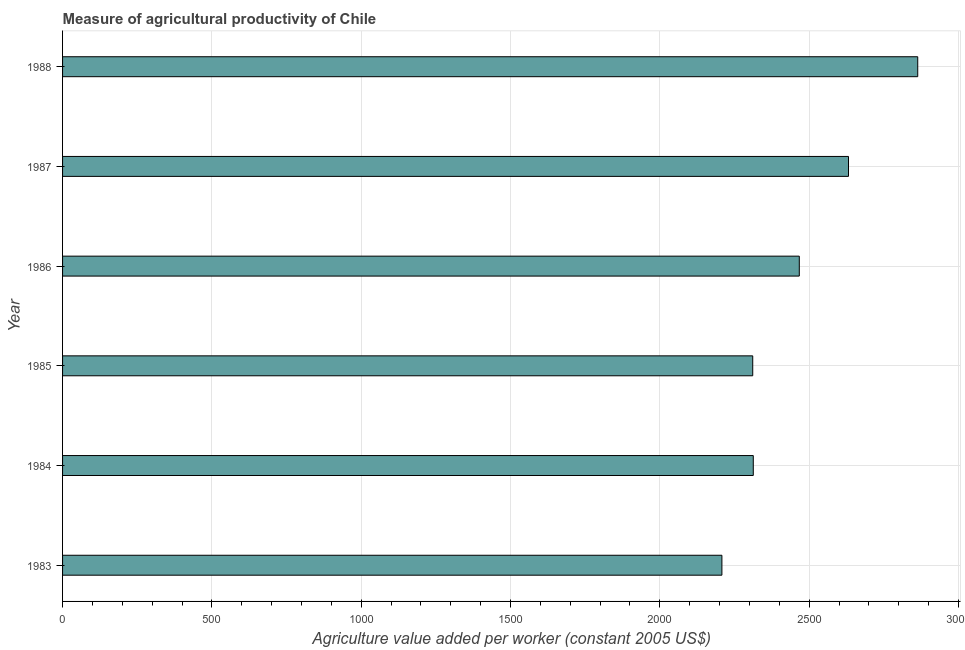What is the title of the graph?
Your answer should be very brief. Measure of agricultural productivity of Chile. What is the label or title of the X-axis?
Offer a terse response. Agriculture value added per worker (constant 2005 US$). What is the agriculture value added per worker in 1988?
Your answer should be very brief. 2863.59. Across all years, what is the maximum agriculture value added per worker?
Provide a short and direct response. 2863.59. Across all years, what is the minimum agriculture value added per worker?
Provide a succinct answer. 2207.87. In which year was the agriculture value added per worker minimum?
Offer a terse response. 1983. What is the sum of the agriculture value added per worker?
Make the answer very short. 1.48e+04. What is the difference between the agriculture value added per worker in 1984 and 1988?
Make the answer very short. -550.69. What is the average agriculture value added per worker per year?
Make the answer very short. 2465.69. What is the median agriculture value added per worker?
Offer a very short reply. 2389.95. In how many years, is the agriculture value added per worker greater than 1900 US$?
Ensure brevity in your answer.  6. What is the ratio of the agriculture value added per worker in 1983 to that in 1985?
Your answer should be very brief. 0.95. Is the agriculture value added per worker in 1984 less than that in 1987?
Provide a short and direct response. Yes. Is the difference between the agriculture value added per worker in 1985 and 1988 greater than the difference between any two years?
Your response must be concise. No. What is the difference between the highest and the second highest agriculture value added per worker?
Your answer should be very brief. 231.84. Is the sum of the agriculture value added per worker in 1985 and 1986 greater than the maximum agriculture value added per worker across all years?
Give a very brief answer. Yes. What is the difference between the highest and the lowest agriculture value added per worker?
Offer a terse response. 655.72. In how many years, is the agriculture value added per worker greater than the average agriculture value added per worker taken over all years?
Provide a succinct answer. 3. How many bars are there?
Provide a short and direct response. 6. What is the Agriculture value added per worker (constant 2005 US$) in 1983?
Offer a terse response. 2207.87. What is the Agriculture value added per worker (constant 2005 US$) in 1984?
Keep it short and to the point. 2312.9. What is the Agriculture value added per worker (constant 2005 US$) in 1985?
Offer a very short reply. 2311.06. What is the Agriculture value added per worker (constant 2005 US$) in 1986?
Provide a succinct answer. 2467. What is the Agriculture value added per worker (constant 2005 US$) in 1987?
Provide a short and direct response. 2631.75. What is the Agriculture value added per worker (constant 2005 US$) of 1988?
Give a very brief answer. 2863.59. What is the difference between the Agriculture value added per worker (constant 2005 US$) in 1983 and 1984?
Ensure brevity in your answer.  -105.04. What is the difference between the Agriculture value added per worker (constant 2005 US$) in 1983 and 1985?
Your response must be concise. -103.2. What is the difference between the Agriculture value added per worker (constant 2005 US$) in 1983 and 1986?
Keep it short and to the point. -259.13. What is the difference between the Agriculture value added per worker (constant 2005 US$) in 1983 and 1987?
Your answer should be compact. -423.88. What is the difference between the Agriculture value added per worker (constant 2005 US$) in 1983 and 1988?
Give a very brief answer. -655.72. What is the difference between the Agriculture value added per worker (constant 2005 US$) in 1984 and 1985?
Your response must be concise. 1.84. What is the difference between the Agriculture value added per worker (constant 2005 US$) in 1984 and 1986?
Offer a terse response. -154.1. What is the difference between the Agriculture value added per worker (constant 2005 US$) in 1984 and 1987?
Make the answer very short. -318.84. What is the difference between the Agriculture value added per worker (constant 2005 US$) in 1984 and 1988?
Give a very brief answer. -550.69. What is the difference between the Agriculture value added per worker (constant 2005 US$) in 1985 and 1986?
Offer a terse response. -155.94. What is the difference between the Agriculture value added per worker (constant 2005 US$) in 1985 and 1987?
Make the answer very short. -320.68. What is the difference between the Agriculture value added per worker (constant 2005 US$) in 1985 and 1988?
Make the answer very short. -552.53. What is the difference between the Agriculture value added per worker (constant 2005 US$) in 1986 and 1987?
Your answer should be compact. -164.75. What is the difference between the Agriculture value added per worker (constant 2005 US$) in 1986 and 1988?
Your response must be concise. -396.59. What is the difference between the Agriculture value added per worker (constant 2005 US$) in 1987 and 1988?
Ensure brevity in your answer.  -231.84. What is the ratio of the Agriculture value added per worker (constant 2005 US$) in 1983 to that in 1984?
Your answer should be compact. 0.95. What is the ratio of the Agriculture value added per worker (constant 2005 US$) in 1983 to that in 1985?
Make the answer very short. 0.95. What is the ratio of the Agriculture value added per worker (constant 2005 US$) in 1983 to that in 1986?
Make the answer very short. 0.9. What is the ratio of the Agriculture value added per worker (constant 2005 US$) in 1983 to that in 1987?
Offer a terse response. 0.84. What is the ratio of the Agriculture value added per worker (constant 2005 US$) in 1983 to that in 1988?
Your response must be concise. 0.77. What is the ratio of the Agriculture value added per worker (constant 2005 US$) in 1984 to that in 1985?
Offer a very short reply. 1. What is the ratio of the Agriculture value added per worker (constant 2005 US$) in 1984 to that in 1986?
Your response must be concise. 0.94. What is the ratio of the Agriculture value added per worker (constant 2005 US$) in 1984 to that in 1987?
Provide a short and direct response. 0.88. What is the ratio of the Agriculture value added per worker (constant 2005 US$) in 1984 to that in 1988?
Give a very brief answer. 0.81. What is the ratio of the Agriculture value added per worker (constant 2005 US$) in 1985 to that in 1986?
Provide a succinct answer. 0.94. What is the ratio of the Agriculture value added per worker (constant 2005 US$) in 1985 to that in 1987?
Your answer should be very brief. 0.88. What is the ratio of the Agriculture value added per worker (constant 2005 US$) in 1985 to that in 1988?
Your answer should be very brief. 0.81. What is the ratio of the Agriculture value added per worker (constant 2005 US$) in 1986 to that in 1987?
Provide a succinct answer. 0.94. What is the ratio of the Agriculture value added per worker (constant 2005 US$) in 1986 to that in 1988?
Give a very brief answer. 0.86. What is the ratio of the Agriculture value added per worker (constant 2005 US$) in 1987 to that in 1988?
Your answer should be compact. 0.92. 